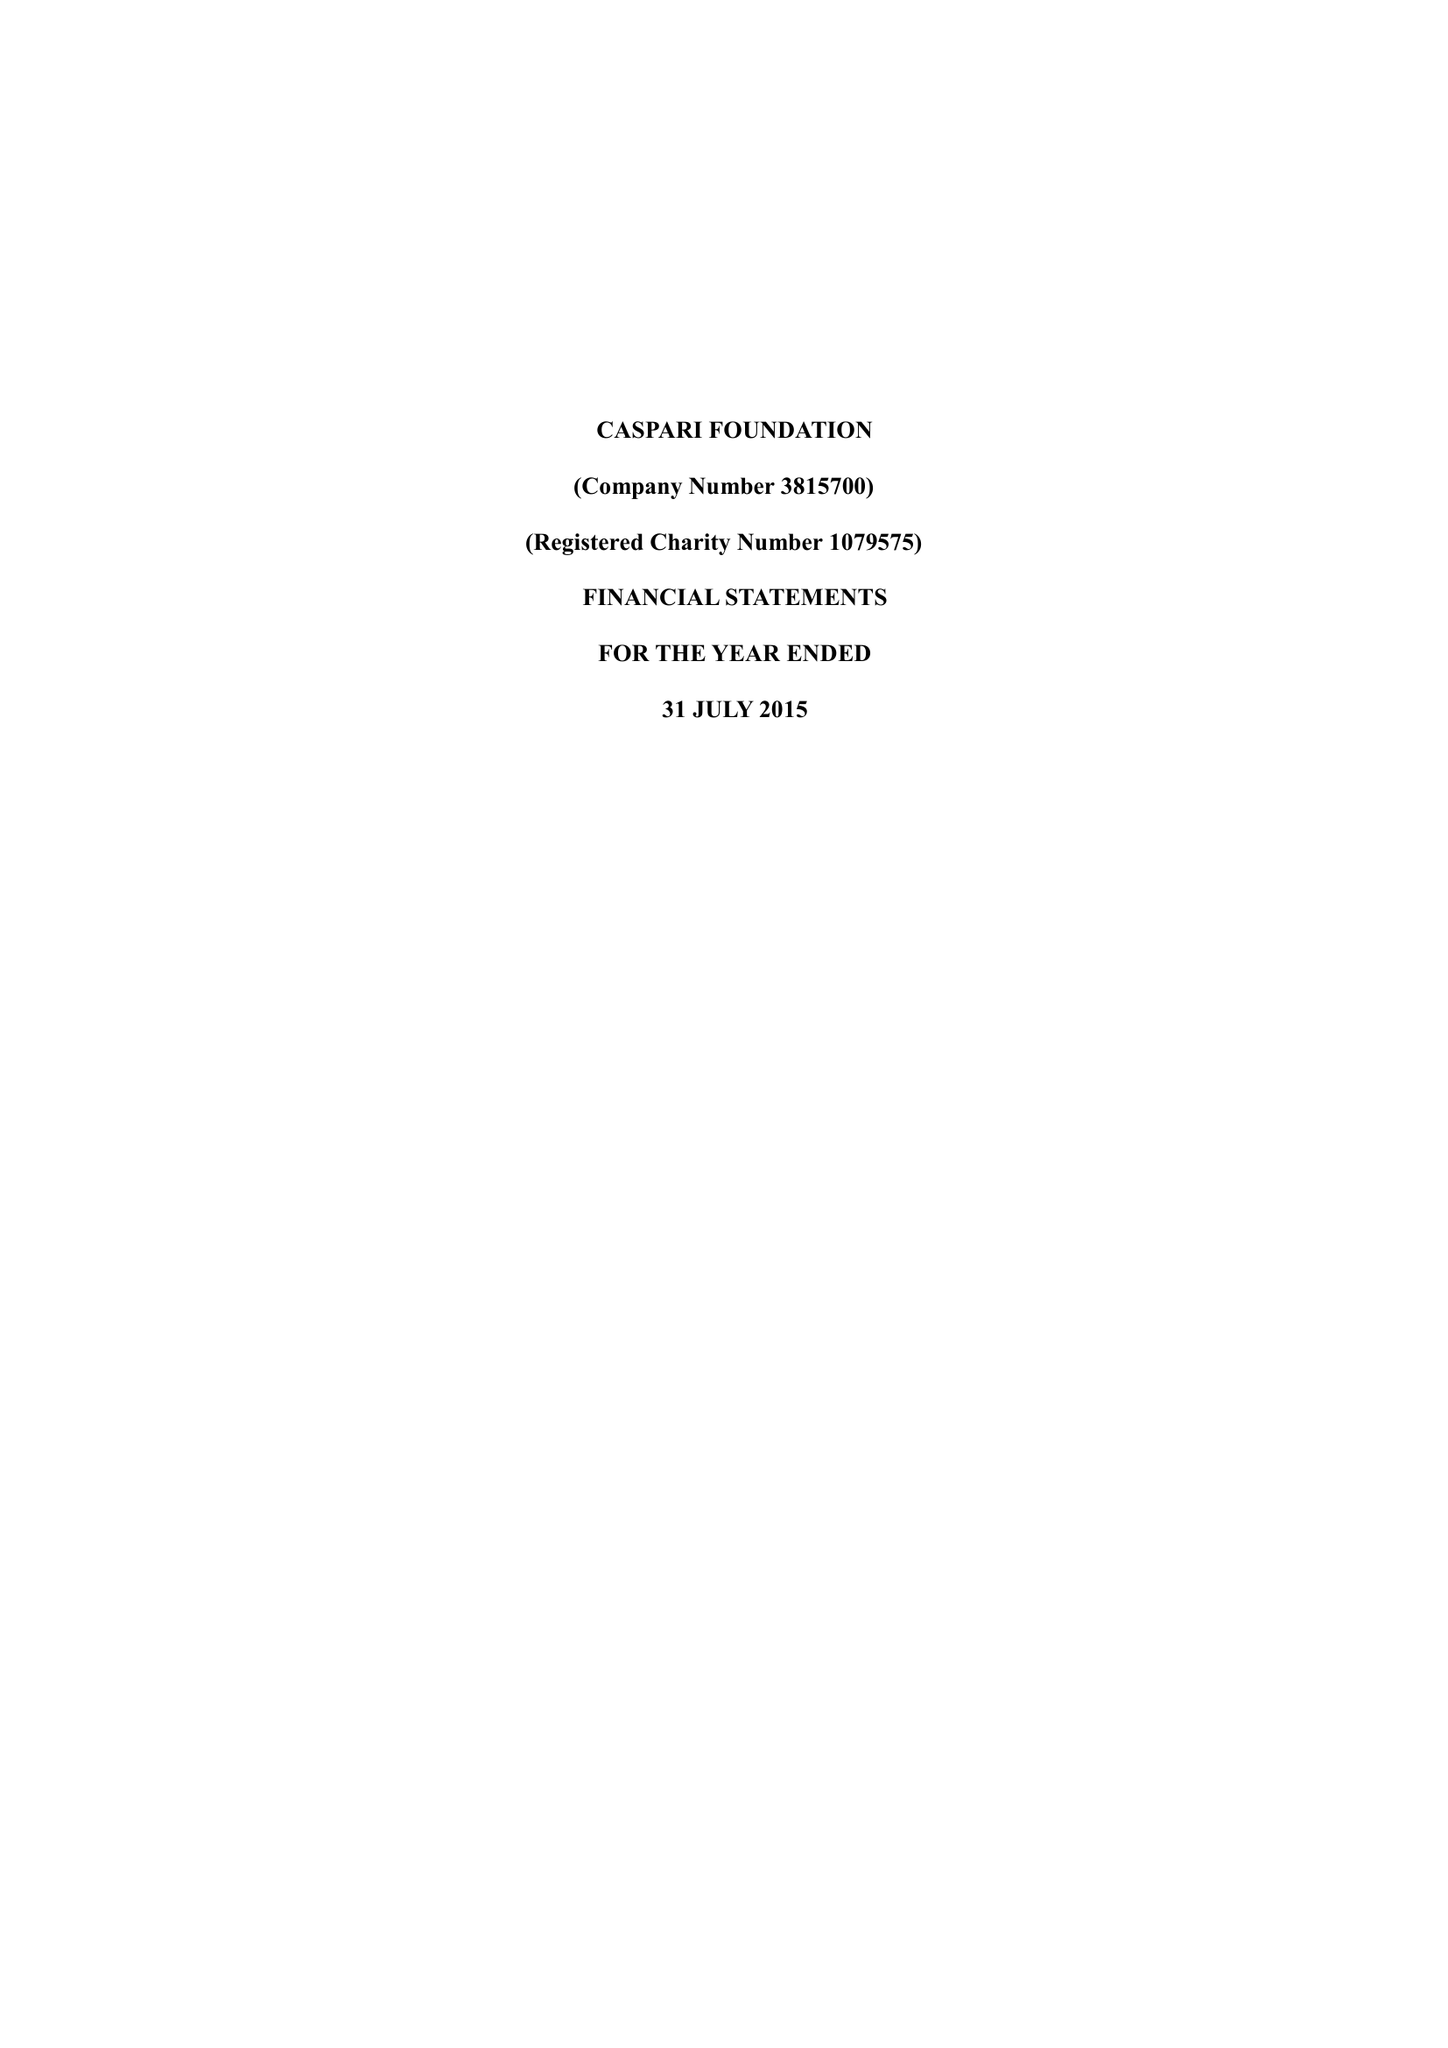What is the value for the address__post_town?
Answer the question using a single word or phrase. LONDON 